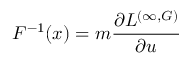Convert formula to latex. <formula><loc_0><loc_0><loc_500><loc_500>F ^ { - 1 } ( x ) = m \frac { \partial L ^ { ( \infty , G ) } } { \partial u }</formula> 